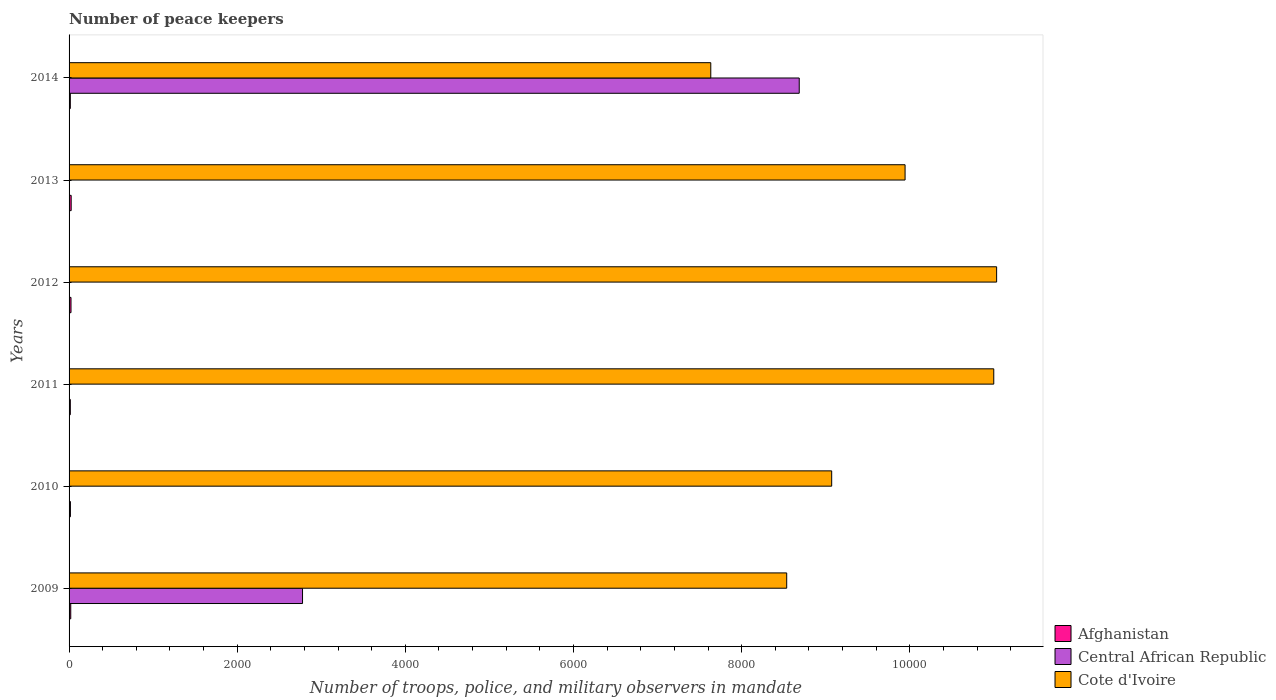What is the label of the 5th group of bars from the top?
Make the answer very short. 2010. What is the number of peace keepers in in Cote d'Ivoire in 2013?
Make the answer very short. 9944. Across all years, what is the maximum number of peace keepers in in Cote d'Ivoire?
Your response must be concise. 1.10e+04. Across all years, what is the minimum number of peace keepers in in Cote d'Ivoire?
Offer a very short reply. 7633. In which year was the number of peace keepers in in Cote d'Ivoire minimum?
Provide a succinct answer. 2014. What is the total number of peace keepers in in Afghanistan in the graph?
Your response must be concise. 114. What is the difference between the number of peace keepers in in Cote d'Ivoire in 2009 and that in 2010?
Give a very brief answer. -535. What is the difference between the number of peace keepers in in Central African Republic in 2009 and the number of peace keepers in in Afghanistan in 2013?
Provide a short and direct response. 2752. In the year 2009, what is the difference between the number of peace keepers in in Afghanistan and number of peace keepers in in Cote d'Ivoire?
Your answer should be very brief. -8516. In how many years, is the number of peace keepers in in Central African Republic greater than 8400 ?
Your response must be concise. 1. What is the ratio of the number of peace keepers in in Central African Republic in 2010 to that in 2014?
Make the answer very short. 0. Is the number of peace keepers in in Cote d'Ivoire in 2009 less than that in 2011?
Provide a short and direct response. Yes. Is the difference between the number of peace keepers in in Afghanistan in 2009 and 2013 greater than the difference between the number of peace keepers in in Cote d'Ivoire in 2009 and 2013?
Provide a succinct answer. Yes. What is the difference between the highest and the second highest number of peace keepers in in Central African Republic?
Provide a short and direct response. 5908. What is the difference between the highest and the lowest number of peace keepers in in Central African Republic?
Make the answer very short. 8682. In how many years, is the number of peace keepers in in Cote d'Ivoire greater than the average number of peace keepers in in Cote d'Ivoire taken over all years?
Ensure brevity in your answer.  3. What does the 2nd bar from the top in 2011 represents?
Your answer should be very brief. Central African Republic. What does the 1st bar from the bottom in 2012 represents?
Keep it short and to the point. Afghanistan. How many bars are there?
Offer a very short reply. 18. Are all the bars in the graph horizontal?
Provide a short and direct response. Yes. What is the difference between two consecutive major ticks on the X-axis?
Keep it short and to the point. 2000. Are the values on the major ticks of X-axis written in scientific E-notation?
Provide a short and direct response. No. Does the graph contain any zero values?
Offer a very short reply. No. Does the graph contain grids?
Keep it short and to the point. No. Where does the legend appear in the graph?
Provide a succinct answer. Bottom right. How are the legend labels stacked?
Keep it short and to the point. Vertical. What is the title of the graph?
Your answer should be very brief. Number of peace keepers. What is the label or title of the X-axis?
Your response must be concise. Number of troops, police, and military observers in mandate. What is the Number of troops, police, and military observers in mandate in Central African Republic in 2009?
Your answer should be very brief. 2777. What is the Number of troops, police, and military observers in mandate in Cote d'Ivoire in 2009?
Give a very brief answer. 8536. What is the Number of troops, police, and military observers in mandate in Central African Republic in 2010?
Offer a very short reply. 3. What is the Number of troops, police, and military observers in mandate of Cote d'Ivoire in 2010?
Offer a very short reply. 9071. What is the Number of troops, police, and military observers in mandate in Central African Republic in 2011?
Make the answer very short. 4. What is the Number of troops, police, and military observers in mandate of Cote d'Ivoire in 2011?
Provide a succinct answer. 1.10e+04. What is the Number of troops, police, and military observers in mandate of Afghanistan in 2012?
Your answer should be compact. 23. What is the Number of troops, police, and military observers in mandate of Cote d'Ivoire in 2012?
Provide a succinct answer. 1.10e+04. What is the Number of troops, police, and military observers in mandate of Central African Republic in 2013?
Your answer should be compact. 4. What is the Number of troops, police, and military observers in mandate of Cote d'Ivoire in 2013?
Provide a short and direct response. 9944. What is the Number of troops, police, and military observers in mandate in Central African Republic in 2014?
Offer a very short reply. 8685. What is the Number of troops, police, and military observers in mandate of Cote d'Ivoire in 2014?
Provide a short and direct response. 7633. Across all years, what is the maximum Number of troops, police, and military observers in mandate in Central African Republic?
Offer a terse response. 8685. Across all years, what is the maximum Number of troops, police, and military observers in mandate of Cote d'Ivoire?
Your answer should be very brief. 1.10e+04. Across all years, what is the minimum Number of troops, police, and military observers in mandate of Central African Republic?
Ensure brevity in your answer.  3. Across all years, what is the minimum Number of troops, police, and military observers in mandate in Cote d'Ivoire?
Your answer should be compact. 7633. What is the total Number of troops, police, and military observers in mandate of Afghanistan in the graph?
Make the answer very short. 114. What is the total Number of troops, police, and military observers in mandate of Central African Republic in the graph?
Provide a succinct answer. 1.15e+04. What is the total Number of troops, police, and military observers in mandate of Cote d'Ivoire in the graph?
Provide a succinct answer. 5.72e+04. What is the difference between the Number of troops, police, and military observers in mandate in Afghanistan in 2009 and that in 2010?
Keep it short and to the point. 4. What is the difference between the Number of troops, police, and military observers in mandate in Central African Republic in 2009 and that in 2010?
Your answer should be very brief. 2774. What is the difference between the Number of troops, police, and military observers in mandate in Cote d'Ivoire in 2009 and that in 2010?
Your answer should be compact. -535. What is the difference between the Number of troops, police, and military observers in mandate of Central African Republic in 2009 and that in 2011?
Your answer should be very brief. 2773. What is the difference between the Number of troops, police, and military observers in mandate in Cote d'Ivoire in 2009 and that in 2011?
Make the answer very short. -2463. What is the difference between the Number of troops, police, and military observers in mandate of Afghanistan in 2009 and that in 2012?
Make the answer very short. -3. What is the difference between the Number of troops, police, and military observers in mandate in Central African Republic in 2009 and that in 2012?
Keep it short and to the point. 2773. What is the difference between the Number of troops, police, and military observers in mandate in Cote d'Ivoire in 2009 and that in 2012?
Offer a very short reply. -2497. What is the difference between the Number of troops, police, and military observers in mandate in Central African Republic in 2009 and that in 2013?
Provide a succinct answer. 2773. What is the difference between the Number of troops, police, and military observers in mandate in Cote d'Ivoire in 2009 and that in 2013?
Your answer should be compact. -1408. What is the difference between the Number of troops, police, and military observers in mandate of Afghanistan in 2009 and that in 2014?
Your answer should be very brief. 5. What is the difference between the Number of troops, police, and military observers in mandate in Central African Republic in 2009 and that in 2014?
Ensure brevity in your answer.  -5908. What is the difference between the Number of troops, police, and military observers in mandate in Cote d'Ivoire in 2009 and that in 2014?
Your answer should be compact. 903. What is the difference between the Number of troops, police, and military observers in mandate in Cote d'Ivoire in 2010 and that in 2011?
Your response must be concise. -1928. What is the difference between the Number of troops, police, and military observers in mandate of Afghanistan in 2010 and that in 2012?
Make the answer very short. -7. What is the difference between the Number of troops, police, and military observers in mandate in Cote d'Ivoire in 2010 and that in 2012?
Keep it short and to the point. -1962. What is the difference between the Number of troops, police, and military observers in mandate in Afghanistan in 2010 and that in 2013?
Keep it short and to the point. -9. What is the difference between the Number of troops, police, and military observers in mandate in Central African Republic in 2010 and that in 2013?
Your answer should be very brief. -1. What is the difference between the Number of troops, police, and military observers in mandate in Cote d'Ivoire in 2010 and that in 2013?
Keep it short and to the point. -873. What is the difference between the Number of troops, police, and military observers in mandate of Central African Republic in 2010 and that in 2014?
Offer a very short reply. -8682. What is the difference between the Number of troops, police, and military observers in mandate in Cote d'Ivoire in 2010 and that in 2014?
Your answer should be compact. 1438. What is the difference between the Number of troops, police, and military observers in mandate in Central African Republic in 2011 and that in 2012?
Your answer should be very brief. 0. What is the difference between the Number of troops, police, and military observers in mandate of Cote d'Ivoire in 2011 and that in 2012?
Your answer should be very brief. -34. What is the difference between the Number of troops, police, and military observers in mandate in Central African Republic in 2011 and that in 2013?
Give a very brief answer. 0. What is the difference between the Number of troops, police, and military observers in mandate of Cote d'Ivoire in 2011 and that in 2013?
Give a very brief answer. 1055. What is the difference between the Number of troops, police, and military observers in mandate of Central African Republic in 2011 and that in 2014?
Make the answer very short. -8681. What is the difference between the Number of troops, police, and military observers in mandate of Cote d'Ivoire in 2011 and that in 2014?
Your answer should be very brief. 3366. What is the difference between the Number of troops, police, and military observers in mandate in Afghanistan in 2012 and that in 2013?
Provide a short and direct response. -2. What is the difference between the Number of troops, police, and military observers in mandate in Central African Republic in 2012 and that in 2013?
Provide a succinct answer. 0. What is the difference between the Number of troops, police, and military observers in mandate of Cote d'Ivoire in 2012 and that in 2013?
Offer a very short reply. 1089. What is the difference between the Number of troops, police, and military observers in mandate in Afghanistan in 2012 and that in 2014?
Keep it short and to the point. 8. What is the difference between the Number of troops, police, and military observers in mandate of Central African Republic in 2012 and that in 2014?
Provide a short and direct response. -8681. What is the difference between the Number of troops, police, and military observers in mandate of Cote d'Ivoire in 2012 and that in 2014?
Provide a succinct answer. 3400. What is the difference between the Number of troops, police, and military observers in mandate in Central African Republic in 2013 and that in 2014?
Give a very brief answer. -8681. What is the difference between the Number of troops, police, and military observers in mandate in Cote d'Ivoire in 2013 and that in 2014?
Provide a short and direct response. 2311. What is the difference between the Number of troops, police, and military observers in mandate of Afghanistan in 2009 and the Number of troops, police, and military observers in mandate of Cote d'Ivoire in 2010?
Provide a succinct answer. -9051. What is the difference between the Number of troops, police, and military observers in mandate in Central African Republic in 2009 and the Number of troops, police, and military observers in mandate in Cote d'Ivoire in 2010?
Ensure brevity in your answer.  -6294. What is the difference between the Number of troops, police, and military observers in mandate in Afghanistan in 2009 and the Number of troops, police, and military observers in mandate in Cote d'Ivoire in 2011?
Give a very brief answer. -1.10e+04. What is the difference between the Number of troops, police, and military observers in mandate in Central African Republic in 2009 and the Number of troops, police, and military observers in mandate in Cote d'Ivoire in 2011?
Give a very brief answer. -8222. What is the difference between the Number of troops, police, and military observers in mandate of Afghanistan in 2009 and the Number of troops, police, and military observers in mandate of Central African Republic in 2012?
Offer a very short reply. 16. What is the difference between the Number of troops, police, and military observers in mandate of Afghanistan in 2009 and the Number of troops, police, and military observers in mandate of Cote d'Ivoire in 2012?
Provide a succinct answer. -1.10e+04. What is the difference between the Number of troops, police, and military observers in mandate in Central African Republic in 2009 and the Number of troops, police, and military observers in mandate in Cote d'Ivoire in 2012?
Your answer should be compact. -8256. What is the difference between the Number of troops, police, and military observers in mandate in Afghanistan in 2009 and the Number of troops, police, and military observers in mandate in Cote d'Ivoire in 2013?
Make the answer very short. -9924. What is the difference between the Number of troops, police, and military observers in mandate in Central African Republic in 2009 and the Number of troops, police, and military observers in mandate in Cote d'Ivoire in 2013?
Give a very brief answer. -7167. What is the difference between the Number of troops, police, and military observers in mandate in Afghanistan in 2009 and the Number of troops, police, and military observers in mandate in Central African Republic in 2014?
Make the answer very short. -8665. What is the difference between the Number of troops, police, and military observers in mandate in Afghanistan in 2009 and the Number of troops, police, and military observers in mandate in Cote d'Ivoire in 2014?
Provide a short and direct response. -7613. What is the difference between the Number of troops, police, and military observers in mandate in Central African Republic in 2009 and the Number of troops, police, and military observers in mandate in Cote d'Ivoire in 2014?
Make the answer very short. -4856. What is the difference between the Number of troops, police, and military observers in mandate of Afghanistan in 2010 and the Number of troops, police, and military observers in mandate of Cote d'Ivoire in 2011?
Provide a succinct answer. -1.10e+04. What is the difference between the Number of troops, police, and military observers in mandate of Central African Republic in 2010 and the Number of troops, police, and military observers in mandate of Cote d'Ivoire in 2011?
Your answer should be very brief. -1.10e+04. What is the difference between the Number of troops, police, and military observers in mandate in Afghanistan in 2010 and the Number of troops, police, and military observers in mandate in Cote d'Ivoire in 2012?
Provide a succinct answer. -1.10e+04. What is the difference between the Number of troops, police, and military observers in mandate of Central African Republic in 2010 and the Number of troops, police, and military observers in mandate of Cote d'Ivoire in 2012?
Make the answer very short. -1.10e+04. What is the difference between the Number of troops, police, and military observers in mandate in Afghanistan in 2010 and the Number of troops, police, and military observers in mandate in Cote d'Ivoire in 2013?
Your answer should be very brief. -9928. What is the difference between the Number of troops, police, and military observers in mandate in Central African Republic in 2010 and the Number of troops, police, and military observers in mandate in Cote d'Ivoire in 2013?
Provide a succinct answer. -9941. What is the difference between the Number of troops, police, and military observers in mandate in Afghanistan in 2010 and the Number of troops, police, and military observers in mandate in Central African Republic in 2014?
Make the answer very short. -8669. What is the difference between the Number of troops, police, and military observers in mandate of Afghanistan in 2010 and the Number of troops, police, and military observers in mandate of Cote d'Ivoire in 2014?
Your answer should be compact. -7617. What is the difference between the Number of troops, police, and military observers in mandate of Central African Republic in 2010 and the Number of troops, police, and military observers in mandate of Cote d'Ivoire in 2014?
Your response must be concise. -7630. What is the difference between the Number of troops, police, and military observers in mandate of Afghanistan in 2011 and the Number of troops, police, and military observers in mandate of Cote d'Ivoire in 2012?
Offer a terse response. -1.10e+04. What is the difference between the Number of troops, police, and military observers in mandate of Central African Republic in 2011 and the Number of troops, police, and military observers in mandate of Cote d'Ivoire in 2012?
Your response must be concise. -1.10e+04. What is the difference between the Number of troops, police, and military observers in mandate in Afghanistan in 2011 and the Number of troops, police, and military observers in mandate in Central African Republic in 2013?
Make the answer very short. 11. What is the difference between the Number of troops, police, and military observers in mandate in Afghanistan in 2011 and the Number of troops, police, and military observers in mandate in Cote d'Ivoire in 2013?
Your response must be concise. -9929. What is the difference between the Number of troops, police, and military observers in mandate of Central African Republic in 2011 and the Number of troops, police, and military observers in mandate of Cote d'Ivoire in 2013?
Offer a very short reply. -9940. What is the difference between the Number of troops, police, and military observers in mandate in Afghanistan in 2011 and the Number of troops, police, and military observers in mandate in Central African Republic in 2014?
Provide a succinct answer. -8670. What is the difference between the Number of troops, police, and military observers in mandate in Afghanistan in 2011 and the Number of troops, police, and military observers in mandate in Cote d'Ivoire in 2014?
Ensure brevity in your answer.  -7618. What is the difference between the Number of troops, police, and military observers in mandate in Central African Republic in 2011 and the Number of troops, police, and military observers in mandate in Cote d'Ivoire in 2014?
Offer a terse response. -7629. What is the difference between the Number of troops, police, and military observers in mandate in Afghanistan in 2012 and the Number of troops, police, and military observers in mandate in Cote d'Ivoire in 2013?
Provide a short and direct response. -9921. What is the difference between the Number of troops, police, and military observers in mandate in Central African Republic in 2012 and the Number of troops, police, and military observers in mandate in Cote d'Ivoire in 2013?
Provide a succinct answer. -9940. What is the difference between the Number of troops, police, and military observers in mandate of Afghanistan in 2012 and the Number of troops, police, and military observers in mandate of Central African Republic in 2014?
Offer a terse response. -8662. What is the difference between the Number of troops, police, and military observers in mandate of Afghanistan in 2012 and the Number of troops, police, and military observers in mandate of Cote d'Ivoire in 2014?
Keep it short and to the point. -7610. What is the difference between the Number of troops, police, and military observers in mandate of Central African Republic in 2012 and the Number of troops, police, and military observers in mandate of Cote d'Ivoire in 2014?
Provide a short and direct response. -7629. What is the difference between the Number of troops, police, and military observers in mandate of Afghanistan in 2013 and the Number of troops, police, and military observers in mandate of Central African Republic in 2014?
Give a very brief answer. -8660. What is the difference between the Number of troops, police, and military observers in mandate of Afghanistan in 2013 and the Number of troops, police, and military observers in mandate of Cote d'Ivoire in 2014?
Your answer should be compact. -7608. What is the difference between the Number of troops, police, and military observers in mandate of Central African Republic in 2013 and the Number of troops, police, and military observers in mandate of Cote d'Ivoire in 2014?
Provide a short and direct response. -7629. What is the average Number of troops, police, and military observers in mandate of Afghanistan per year?
Keep it short and to the point. 19. What is the average Number of troops, police, and military observers in mandate of Central African Republic per year?
Your answer should be compact. 1912.83. What is the average Number of troops, police, and military observers in mandate of Cote d'Ivoire per year?
Offer a very short reply. 9536. In the year 2009, what is the difference between the Number of troops, police, and military observers in mandate in Afghanistan and Number of troops, police, and military observers in mandate in Central African Republic?
Make the answer very short. -2757. In the year 2009, what is the difference between the Number of troops, police, and military observers in mandate of Afghanistan and Number of troops, police, and military observers in mandate of Cote d'Ivoire?
Offer a terse response. -8516. In the year 2009, what is the difference between the Number of troops, police, and military observers in mandate in Central African Republic and Number of troops, police, and military observers in mandate in Cote d'Ivoire?
Provide a succinct answer. -5759. In the year 2010, what is the difference between the Number of troops, police, and military observers in mandate in Afghanistan and Number of troops, police, and military observers in mandate in Central African Republic?
Ensure brevity in your answer.  13. In the year 2010, what is the difference between the Number of troops, police, and military observers in mandate of Afghanistan and Number of troops, police, and military observers in mandate of Cote d'Ivoire?
Your response must be concise. -9055. In the year 2010, what is the difference between the Number of troops, police, and military observers in mandate in Central African Republic and Number of troops, police, and military observers in mandate in Cote d'Ivoire?
Offer a very short reply. -9068. In the year 2011, what is the difference between the Number of troops, police, and military observers in mandate of Afghanistan and Number of troops, police, and military observers in mandate of Central African Republic?
Make the answer very short. 11. In the year 2011, what is the difference between the Number of troops, police, and military observers in mandate of Afghanistan and Number of troops, police, and military observers in mandate of Cote d'Ivoire?
Ensure brevity in your answer.  -1.10e+04. In the year 2011, what is the difference between the Number of troops, police, and military observers in mandate of Central African Republic and Number of troops, police, and military observers in mandate of Cote d'Ivoire?
Keep it short and to the point. -1.10e+04. In the year 2012, what is the difference between the Number of troops, police, and military observers in mandate in Afghanistan and Number of troops, police, and military observers in mandate in Central African Republic?
Your answer should be compact. 19. In the year 2012, what is the difference between the Number of troops, police, and military observers in mandate in Afghanistan and Number of troops, police, and military observers in mandate in Cote d'Ivoire?
Offer a very short reply. -1.10e+04. In the year 2012, what is the difference between the Number of troops, police, and military observers in mandate in Central African Republic and Number of troops, police, and military observers in mandate in Cote d'Ivoire?
Give a very brief answer. -1.10e+04. In the year 2013, what is the difference between the Number of troops, police, and military observers in mandate of Afghanistan and Number of troops, police, and military observers in mandate of Cote d'Ivoire?
Keep it short and to the point. -9919. In the year 2013, what is the difference between the Number of troops, police, and military observers in mandate of Central African Republic and Number of troops, police, and military observers in mandate of Cote d'Ivoire?
Offer a terse response. -9940. In the year 2014, what is the difference between the Number of troops, police, and military observers in mandate of Afghanistan and Number of troops, police, and military observers in mandate of Central African Republic?
Provide a short and direct response. -8670. In the year 2014, what is the difference between the Number of troops, police, and military observers in mandate in Afghanistan and Number of troops, police, and military observers in mandate in Cote d'Ivoire?
Your response must be concise. -7618. In the year 2014, what is the difference between the Number of troops, police, and military observers in mandate in Central African Republic and Number of troops, police, and military observers in mandate in Cote d'Ivoire?
Your answer should be compact. 1052. What is the ratio of the Number of troops, police, and military observers in mandate of Central African Republic in 2009 to that in 2010?
Provide a succinct answer. 925.67. What is the ratio of the Number of troops, police, and military observers in mandate in Cote d'Ivoire in 2009 to that in 2010?
Offer a terse response. 0.94. What is the ratio of the Number of troops, police, and military observers in mandate in Central African Republic in 2009 to that in 2011?
Your answer should be compact. 694.25. What is the ratio of the Number of troops, police, and military observers in mandate of Cote d'Ivoire in 2009 to that in 2011?
Give a very brief answer. 0.78. What is the ratio of the Number of troops, police, and military observers in mandate of Afghanistan in 2009 to that in 2012?
Keep it short and to the point. 0.87. What is the ratio of the Number of troops, police, and military observers in mandate of Central African Republic in 2009 to that in 2012?
Your response must be concise. 694.25. What is the ratio of the Number of troops, police, and military observers in mandate of Cote d'Ivoire in 2009 to that in 2012?
Offer a very short reply. 0.77. What is the ratio of the Number of troops, police, and military observers in mandate of Central African Republic in 2009 to that in 2013?
Provide a short and direct response. 694.25. What is the ratio of the Number of troops, police, and military observers in mandate of Cote d'Ivoire in 2009 to that in 2013?
Your response must be concise. 0.86. What is the ratio of the Number of troops, police, and military observers in mandate in Afghanistan in 2009 to that in 2014?
Ensure brevity in your answer.  1.33. What is the ratio of the Number of troops, police, and military observers in mandate of Central African Republic in 2009 to that in 2014?
Make the answer very short. 0.32. What is the ratio of the Number of troops, police, and military observers in mandate of Cote d'Ivoire in 2009 to that in 2014?
Your answer should be very brief. 1.12. What is the ratio of the Number of troops, police, and military observers in mandate of Afghanistan in 2010 to that in 2011?
Ensure brevity in your answer.  1.07. What is the ratio of the Number of troops, police, and military observers in mandate in Cote d'Ivoire in 2010 to that in 2011?
Offer a very short reply. 0.82. What is the ratio of the Number of troops, police, and military observers in mandate in Afghanistan in 2010 to that in 2012?
Ensure brevity in your answer.  0.7. What is the ratio of the Number of troops, police, and military observers in mandate of Central African Republic in 2010 to that in 2012?
Your response must be concise. 0.75. What is the ratio of the Number of troops, police, and military observers in mandate of Cote d'Ivoire in 2010 to that in 2012?
Your answer should be compact. 0.82. What is the ratio of the Number of troops, police, and military observers in mandate of Afghanistan in 2010 to that in 2013?
Ensure brevity in your answer.  0.64. What is the ratio of the Number of troops, police, and military observers in mandate in Cote d'Ivoire in 2010 to that in 2013?
Ensure brevity in your answer.  0.91. What is the ratio of the Number of troops, police, and military observers in mandate in Afghanistan in 2010 to that in 2014?
Make the answer very short. 1.07. What is the ratio of the Number of troops, police, and military observers in mandate in Cote d'Ivoire in 2010 to that in 2014?
Make the answer very short. 1.19. What is the ratio of the Number of troops, police, and military observers in mandate in Afghanistan in 2011 to that in 2012?
Give a very brief answer. 0.65. What is the ratio of the Number of troops, police, and military observers in mandate of Afghanistan in 2011 to that in 2013?
Your answer should be compact. 0.6. What is the ratio of the Number of troops, police, and military observers in mandate of Central African Republic in 2011 to that in 2013?
Your answer should be compact. 1. What is the ratio of the Number of troops, police, and military observers in mandate of Cote d'Ivoire in 2011 to that in 2013?
Give a very brief answer. 1.11. What is the ratio of the Number of troops, police, and military observers in mandate in Afghanistan in 2011 to that in 2014?
Keep it short and to the point. 1. What is the ratio of the Number of troops, police, and military observers in mandate of Cote d'Ivoire in 2011 to that in 2014?
Provide a succinct answer. 1.44. What is the ratio of the Number of troops, police, and military observers in mandate of Afghanistan in 2012 to that in 2013?
Provide a succinct answer. 0.92. What is the ratio of the Number of troops, police, and military observers in mandate of Central African Republic in 2012 to that in 2013?
Offer a terse response. 1. What is the ratio of the Number of troops, police, and military observers in mandate in Cote d'Ivoire in 2012 to that in 2013?
Offer a very short reply. 1.11. What is the ratio of the Number of troops, police, and military observers in mandate in Afghanistan in 2012 to that in 2014?
Keep it short and to the point. 1.53. What is the ratio of the Number of troops, police, and military observers in mandate of Central African Republic in 2012 to that in 2014?
Provide a succinct answer. 0. What is the ratio of the Number of troops, police, and military observers in mandate in Cote d'Ivoire in 2012 to that in 2014?
Ensure brevity in your answer.  1.45. What is the ratio of the Number of troops, police, and military observers in mandate in Cote d'Ivoire in 2013 to that in 2014?
Give a very brief answer. 1.3. What is the difference between the highest and the second highest Number of troops, police, and military observers in mandate in Afghanistan?
Provide a succinct answer. 2. What is the difference between the highest and the second highest Number of troops, police, and military observers in mandate in Central African Republic?
Keep it short and to the point. 5908. What is the difference between the highest and the second highest Number of troops, police, and military observers in mandate of Cote d'Ivoire?
Provide a succinct answer. 34. What is the difference between the highest and the lowest Number of troops, police, and military observers in mandate in Afghanistan?
Ensure brevity in your answer.  10. What is the difference between the highest and the lowest Number of troops, police, and military observers in mandate of Central African Republic?
Ensure brevity in your answer.  8682. What is the difference between the highest and the lowest Number of troops, police, and military observers in mandate of Cote d'Ivoire?
Ensure brevity in your answer.  3400. 